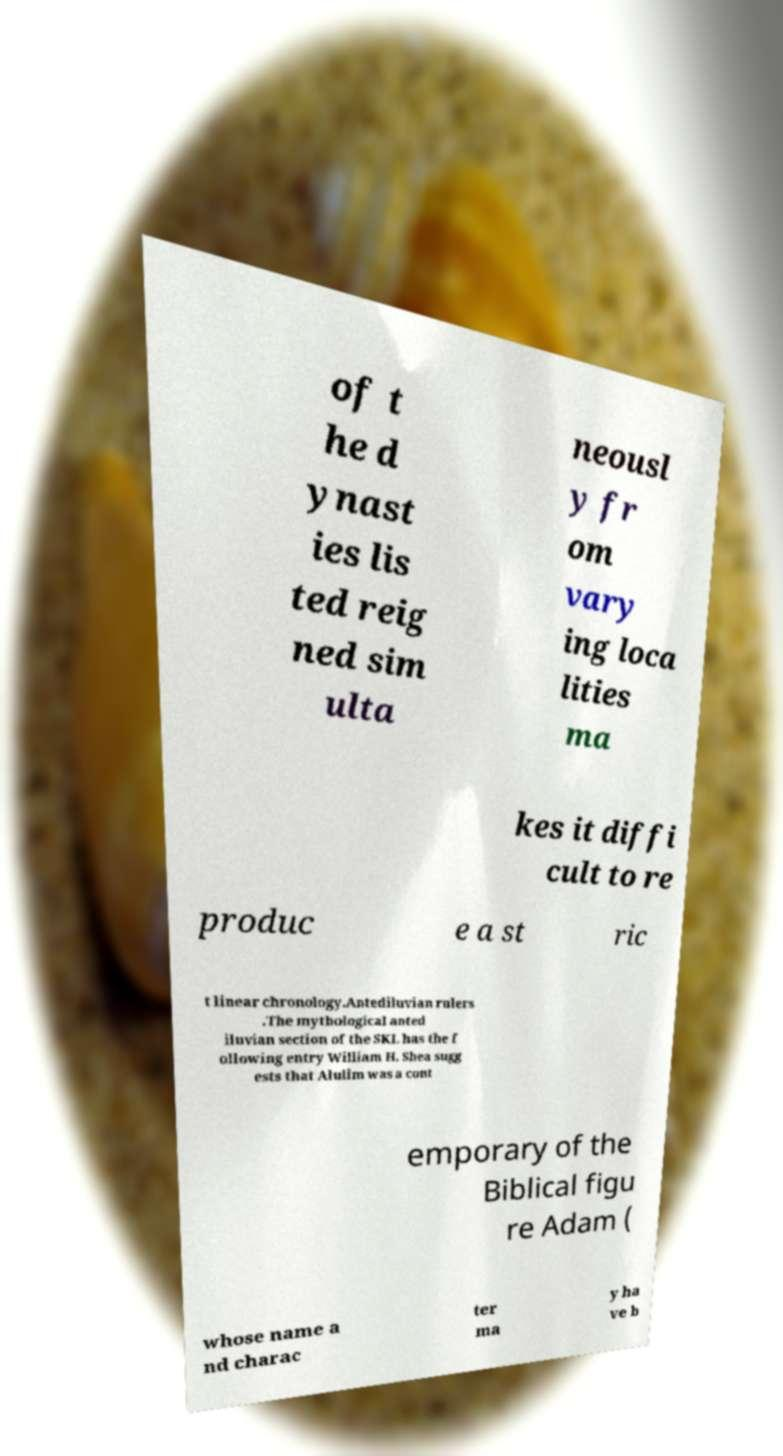Can you read and provide the text displayed in the image?This photo seems to have some interesting text. Can you extract and type it out for me? of t he d ynast ies lis ted reig ned sim ulta neousl y fr om vary ing loca lities ma kes it diffi cult to re produc e a st ric t linear chronology.Antediluvian rulers .The mythological anted iluvian section of the SKL has the f ollowing entry William H. Shea sugg ests that Alulim was a cont emporary of the Biblical figu re Adam ( whose name a nd charac ter ma y ha ve b 